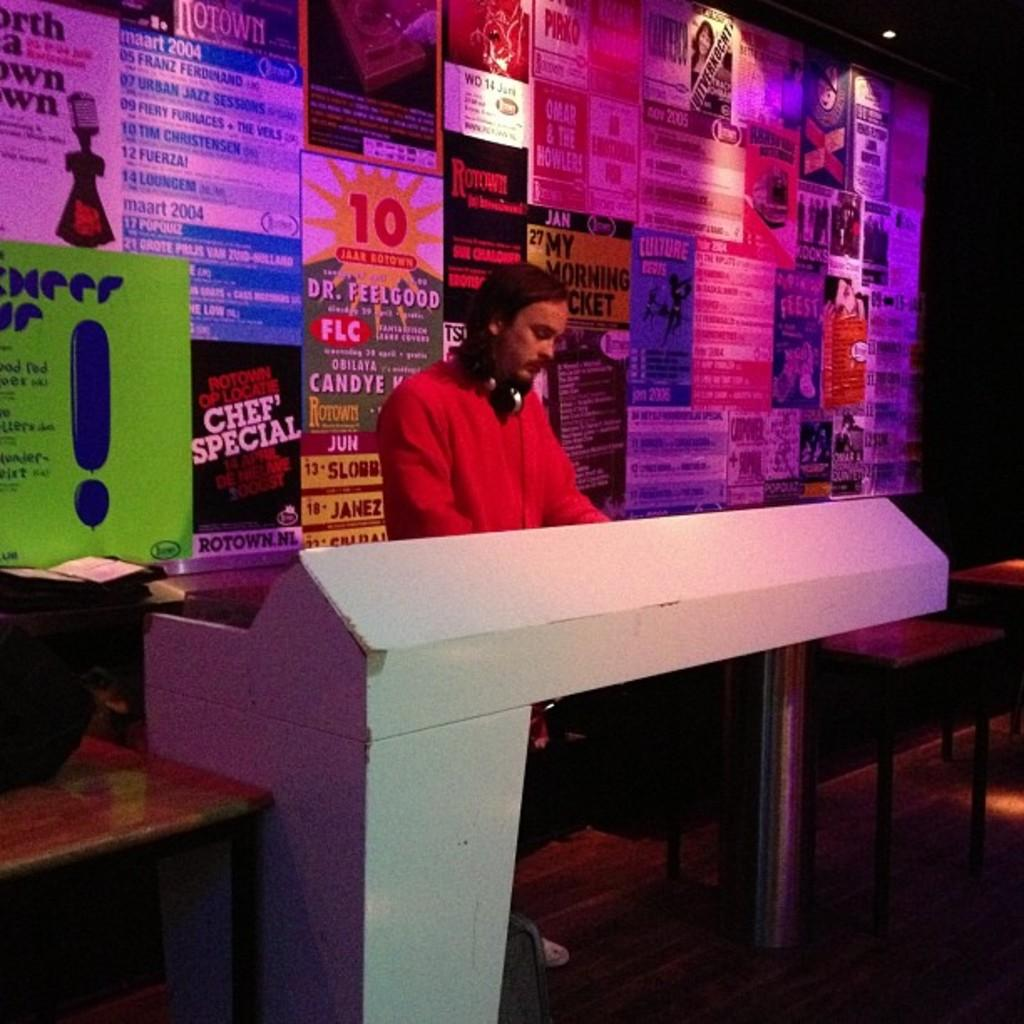<image>
Offer a succinct explanation of the picture presented. A DJ stands in front of a wall of concert posters, including one for Dr. Feelgood. 